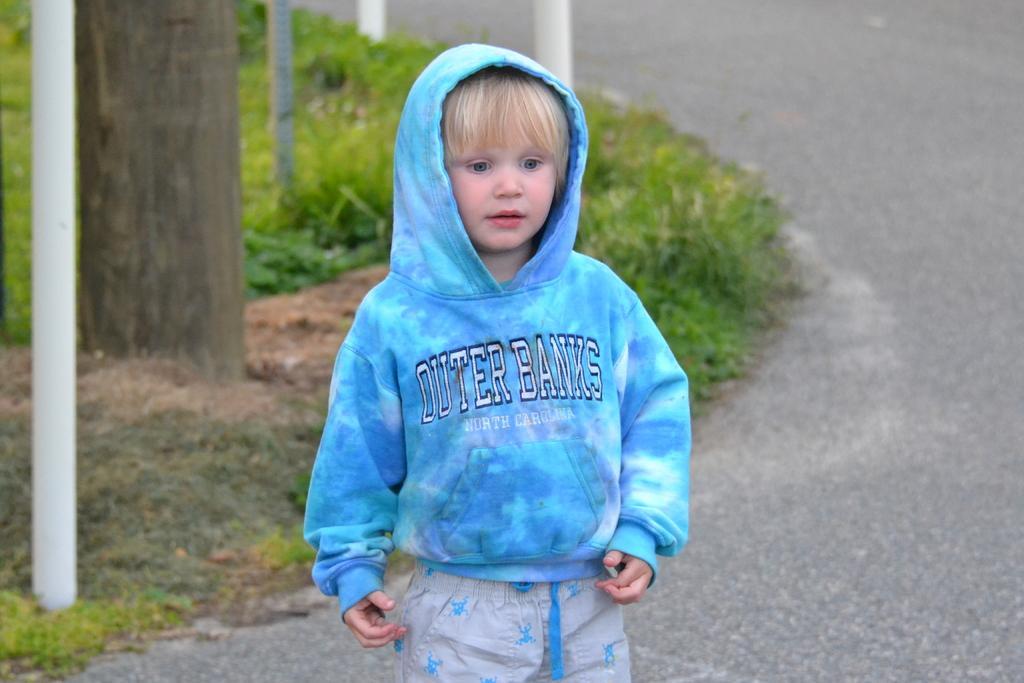How would you summarize this image in a sentence or two? In this picture there is a boy with blue jacket is standing on the road. At the back there is a tree and there are poles. At the bottom there is a road and there is grass and there is ground. 